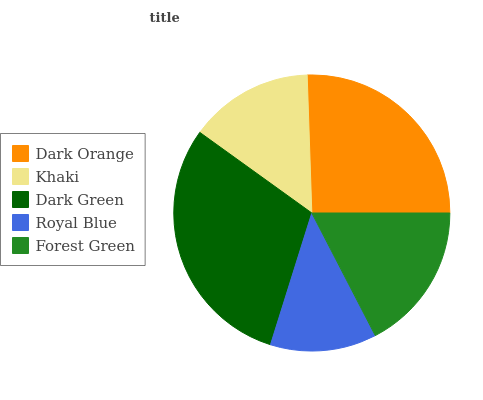Is Royal Blue the minimum?
Answer yes or no. Yes. Is Dark Green the maximum?
Answer yes or no. Yes. Is Khaki the minimum?
Answer yes or no. No. Is Khaki the maximum?
Answer yes or no. No. Is Dark Orange greater than Khaki?
Answer yes or no. Yes. Is Khaki less than Dark Orange?
Answer yes or no. Yes. Is Khaki greater than Dark Orange?
Answer yes or no. No. Is Dark Orange less than Khaki?
Answer yes or no. No. Is Forest Green the high median?
Answer yes or no. Yes. Is Forest Green the low median?
Answer yes or no. Yes. Is Dark Orange the high median?
Answer yes or no. No. Is Khaki the low median?
Answer yes or no. No. 